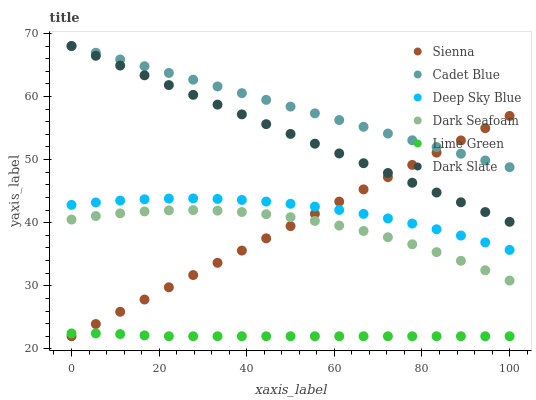Does Lime Green have the minimum area under the curve?
Answer yes or no. Yes. Does Cadet Blue have the maximum area under the curve?
Answer yes or no. Yes. Does Sienna have the minimum area under the curve?
Answer yes or no. No. Does Sienna have the maximum area under the curve?
Answer yes or no. No. Is Sienna the smoothest?
Answer yes or no. Yes. Is Dark Seafoam the roughest?
Answer yes or no. Yes. Is Dark Slate the smoothest?
Answer yes or no. No. Is Dark Slate the roughest?
Answer yes or no. No. Does Sienna have the lowest value?
Answer yes or no. Yes. Does Dark Slate have the lowest value?
Answer yes or no. No. Does Dark Slate have the highest value?
Answer yes or no. Yes. Does Sienna have the highest value?
Answer yes or no. No. Is Dark Seafoam less than Dark Slate?
Answer yes or no. Yes. Is Deep Sky Blue greater than Lime Green?
Answer yes or no. Yes. Does Sienna intersect Deep Sky Blue?
Answer yes or no. Yes. Is Sienna less than Deep Sky Blue?
Answer yes or no. No. Is Sienna greater than Deep Sky Blue?
Answer yes or no. No. Does Dark Seafoam intersect Dark Slate?
Answer yes or no. No. 